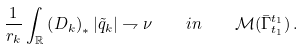<formula> <loc_0><loc_0><loc_500><loc_500>\frac { 1 } { r _ { k } } \int _ { \mathbb { R } } \left ( D _ { k } \right ) _ { * } | \tilde { q } _ { k } | \rightharpoondown \nu \quad i n \quad \mathcal { M } ( \bar { \Gamma } _ { t _ { 1 } } ^ { t _ { 1 } } ) \, .</formula> 